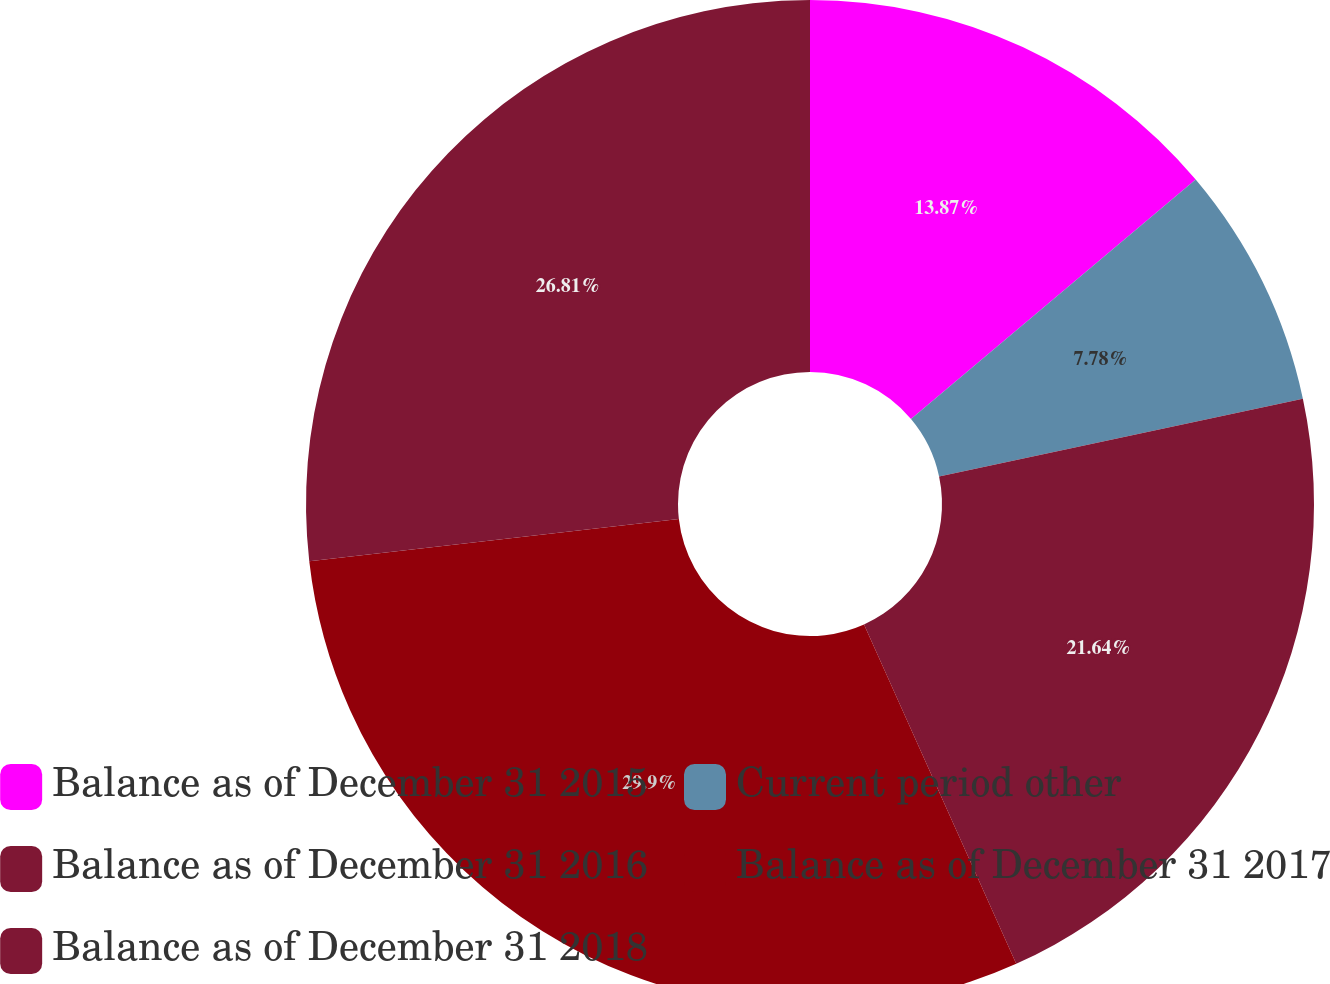Convert chart to OTSL. <chart><loc_0><loc_0><loc_500><loc_500><pie_chart><fcel>Balance as of December 31 2015<fcel>Current period other<fcel>Balance as of December 31 2016<fcel>Balance as of December 31 2017<fcel>Balance as of December 31 2018<nl><fcel>13.87%<fcel>7.78%<fcel>21.64%<fcel>29.9%<fcel>26.81%<nl></chart> 